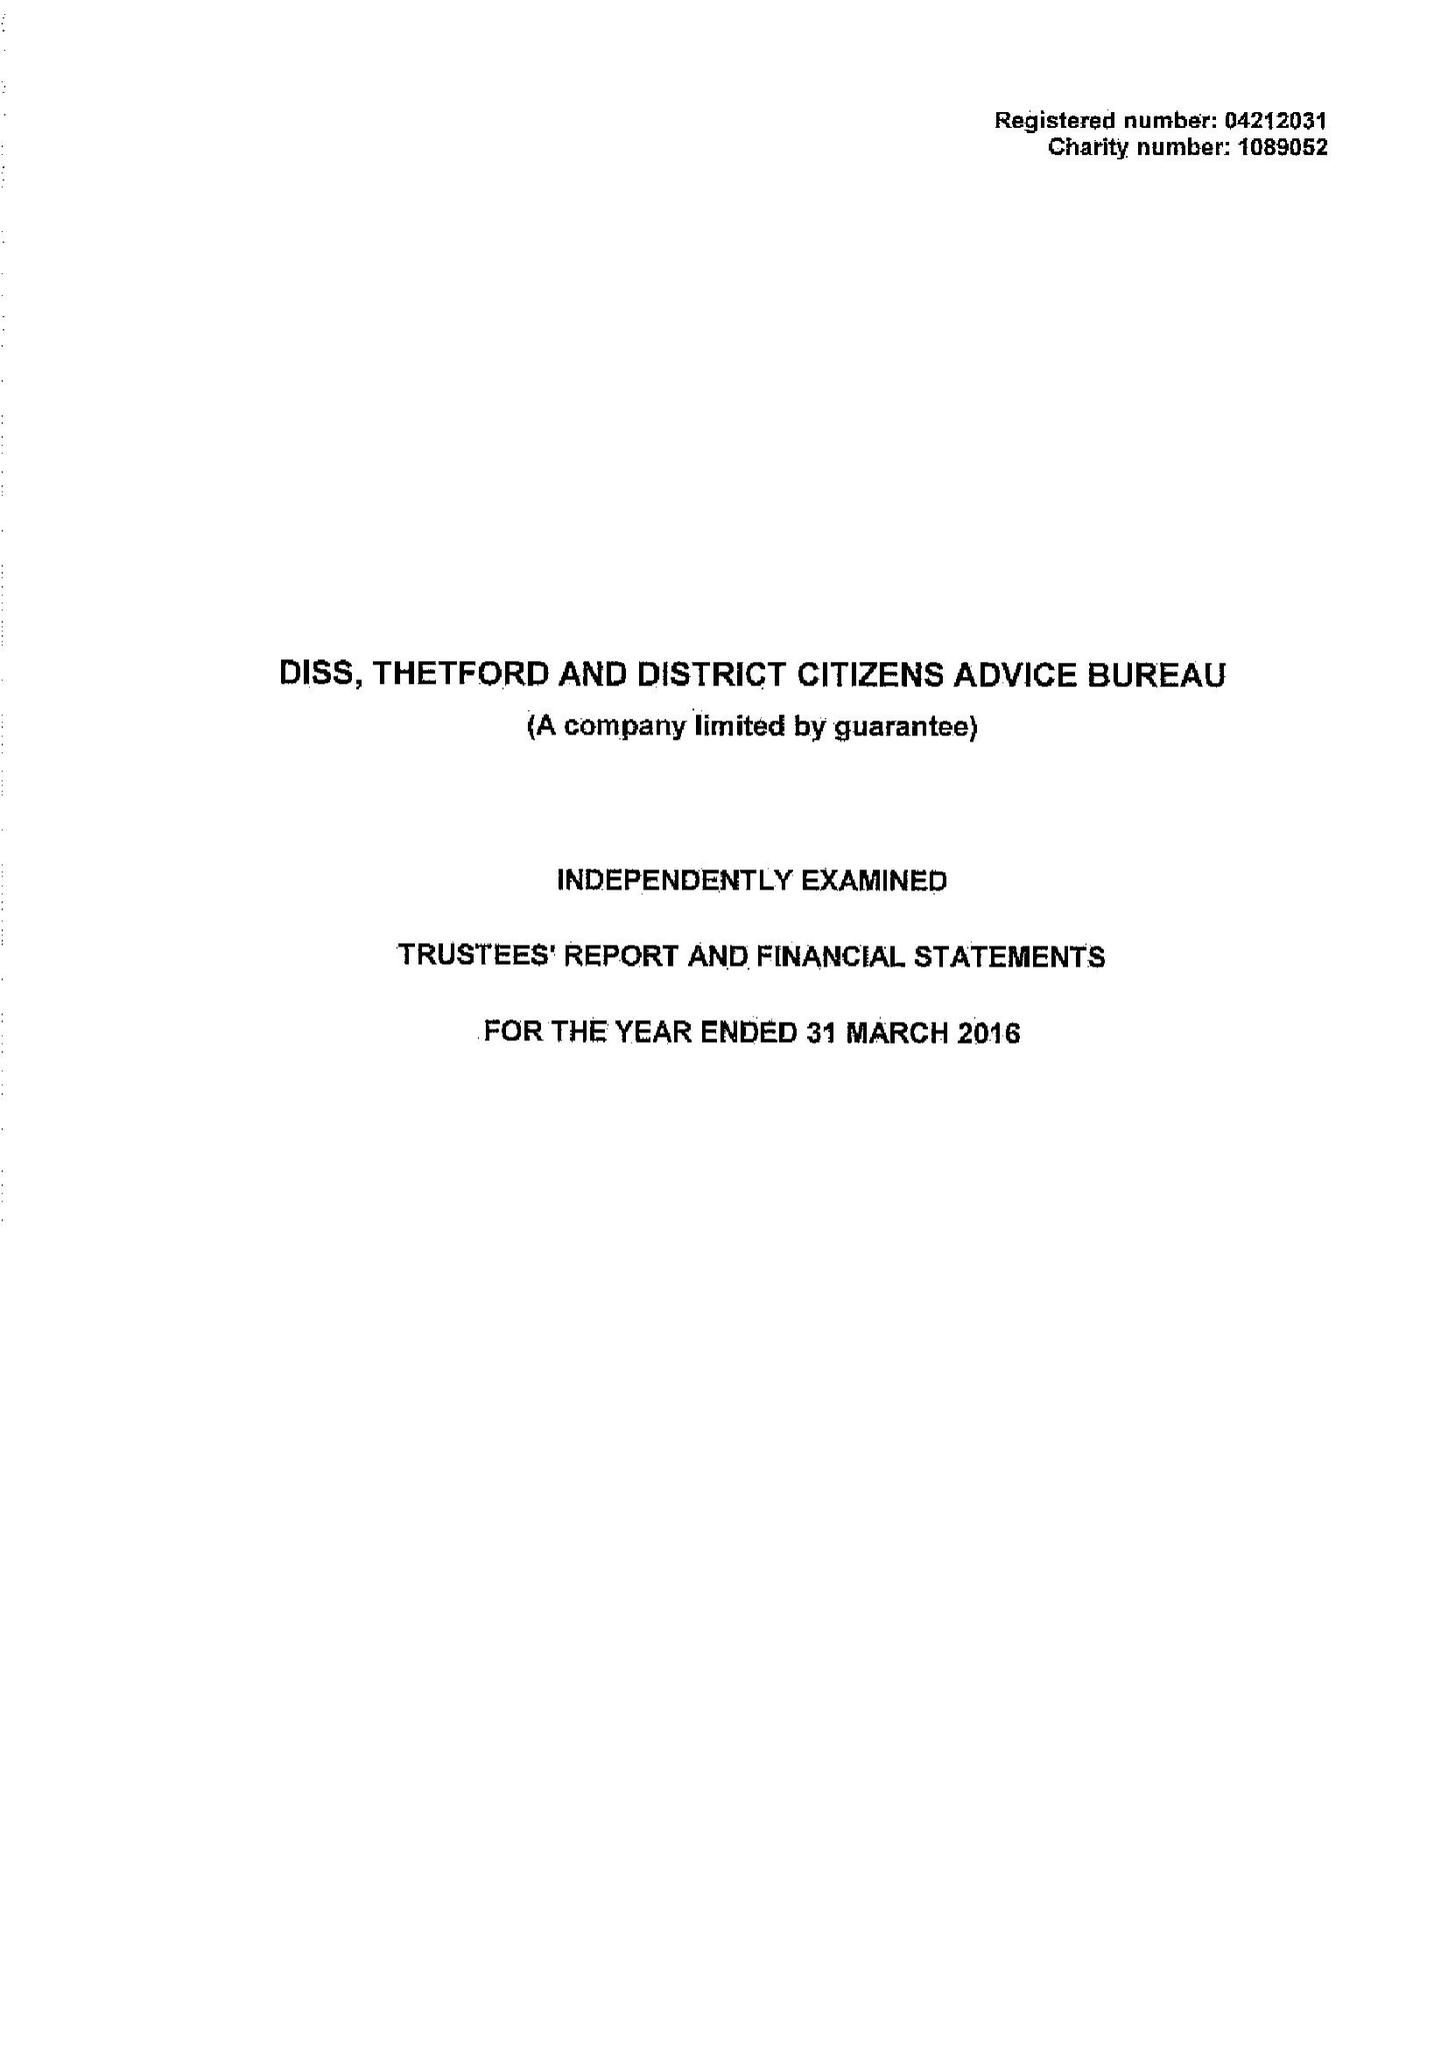What is the value for the charity_number?
Answer the question using a single word or phrase. 1089052 